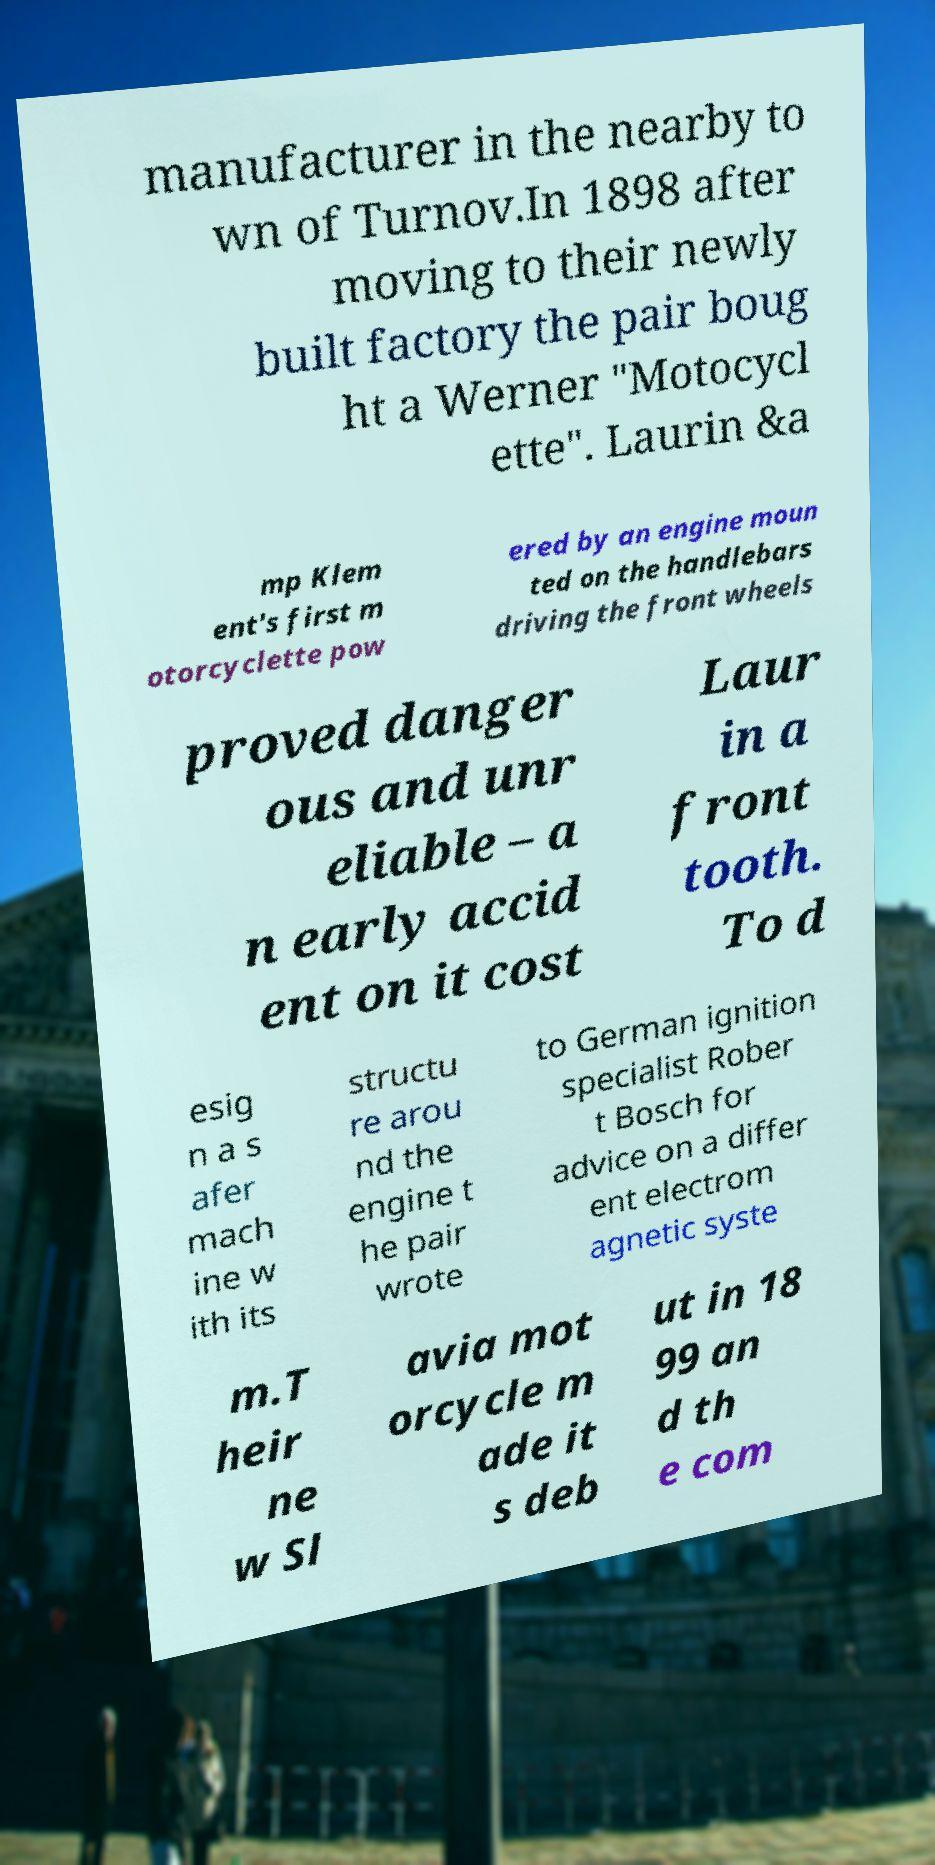I need the written content from this picture converted into text. Can you do that? manufacturer in the nearby to wn of Turnov.In 1898 after moving to their newly built factory the pair boug ht a Werner "Motocycl ette". Laurin &a mp Klem ent's first m otorcyclette pow ered by an engine moun ted on the handlebars driving the front wheels proved danger ous and unr eliable – a n early accid ent on it cost Laur in a front tooth. To d esig n a s afer mach ine w ith its structu re arou nd the engine t he pair wrote to German ignition specialist Rober t Bosch for advice on a differ ent electrom agnetic syste m.T heir ne w Sl avia mot orcycle m ade it s deb ut in 18 99 an d th e com 